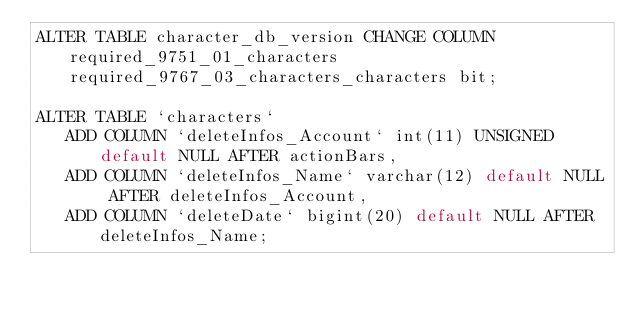Convert code to text. <code><loc_0><loc_0><loc_500><loc_500><_SQL_>ALTER TABLE character_db_version CHANGE COLUMN required_9751_01_characters required_9767_03_characters_characters bit;

ALTER TABLE `characters`
   ADD COLUMN `deleteInfos_Account` int(11) UNSIGNED default NULL AFTER actionBars,
   ADD COLUMN `deleteInfos_Name` varchar(12) default NULL AFTER deleteInfos_Account,
   ADD COLUMN `deleteDate` bigint(20) default NULL AFTER deleteInfos_Name;
</code> 